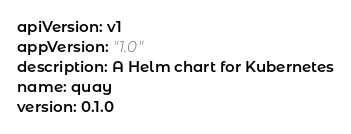Convert code to text. <code><loc_0><loc_0><loc_500><loc_500><_YAML_>apiVersion: v1
appVersion: "1.0"
description: A Helm chart for Kubernetes
name: quay
version: 0.1.0
</code> 